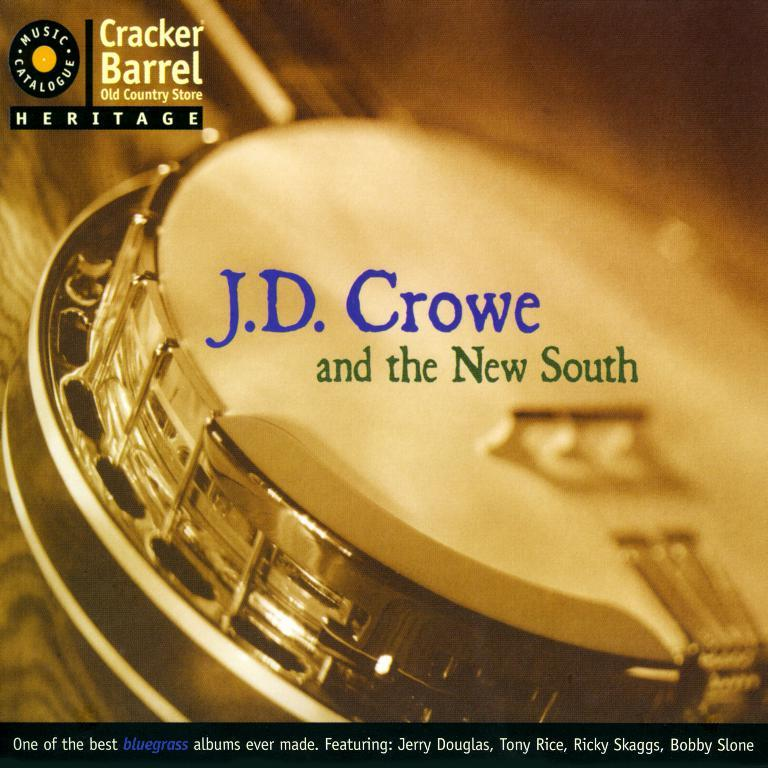<image>
Describe the image concisely. An ad from Cracker Barrel says J.D. Crowe and the New South on it. 